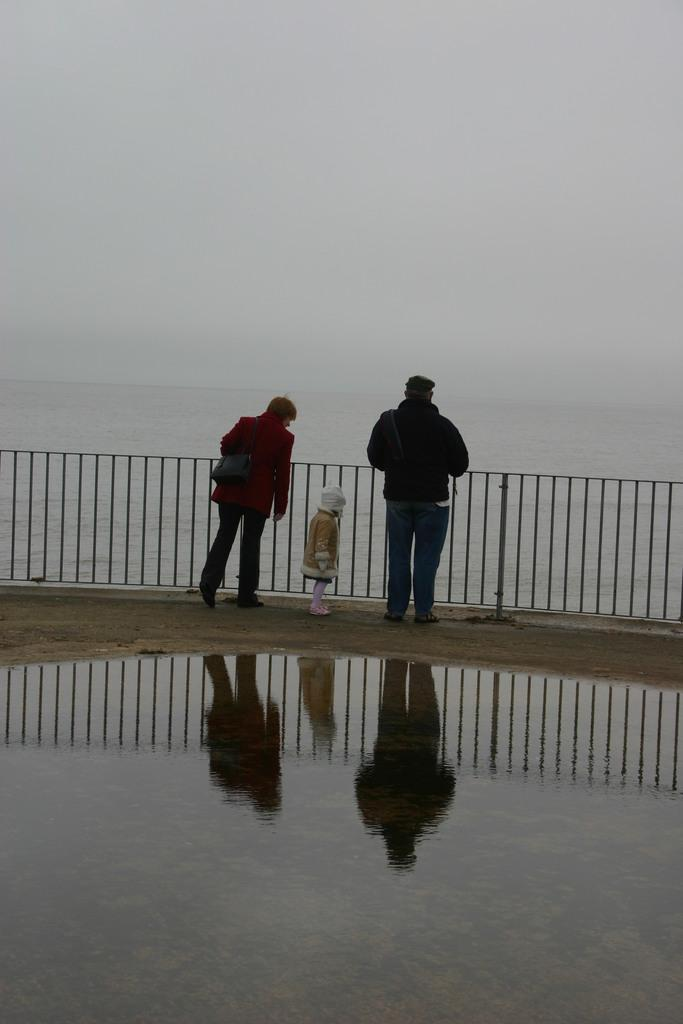How many people are present in the image? There are people in the image, but the exact number is not specified. What is the primary element visible in the image? Water and ground are visible in the image. What is the condition of the ground in the image? There is water on the ground in the image. What type of barrier is present in the image? There is fencing in the image. What can be seen on the ground due to the presence of people? The reflections of persons are visible on the ground. What part of the natural environment is visible in the image? The sky is visible in the image. What type of money is floating on the water in the image? There is no money visible in the image; it only features people, water, ground, fencing, and the sky. 